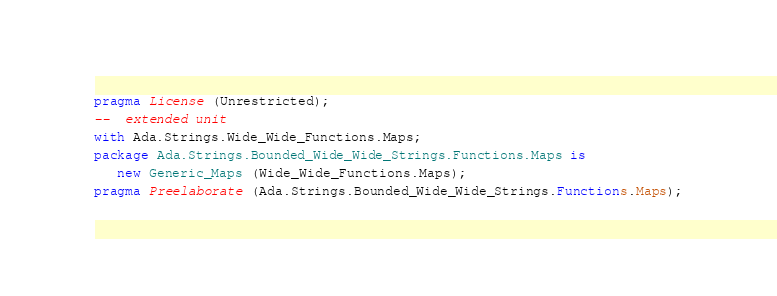<code> <loc_0><loc_0><loc_500><loc_500><_Ada_>pragma License (Unrestricted);
--  extended unit
with Ada.Strings.Wide_Wide_Functions.Maps;
package Ada.Strings.Bounded_Wide_Wide_Strings.Functions.Maps is
   new Generic_Maps (Wide_Wide_Functions.Maps);
pragma Preelaborate (Ada.Strings.Bounded_Wide_Wide_Strings.Functions.Maps);
</code> 